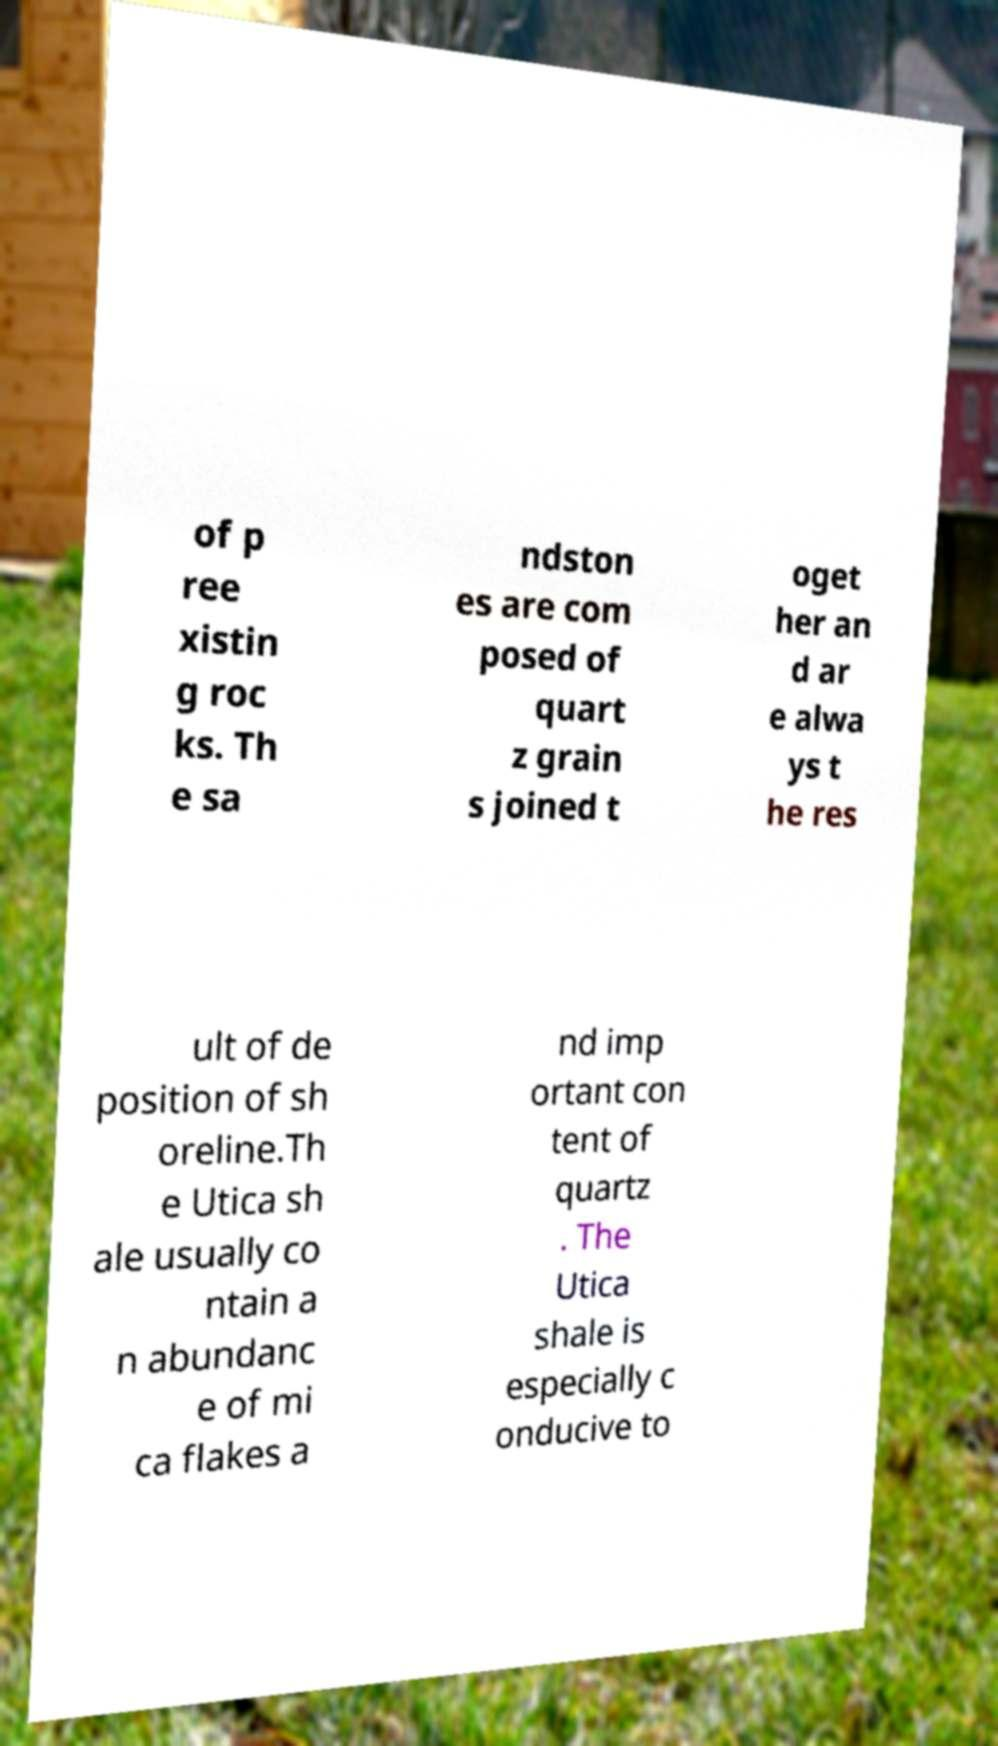Can you accurately transcribe the text from the provided image for me? of p ree xistin g roc ks. Th e sa ndston es are com posed of quart z grain s joined t oget her an d ar e alwa ys t he res ult of de position of sh oreline.Th e Utica sh ale usually co ntain a n abundanc e of mi ca flakes a nd imp ortant con tent of quartz . The Utica shale is especially c onducive to 